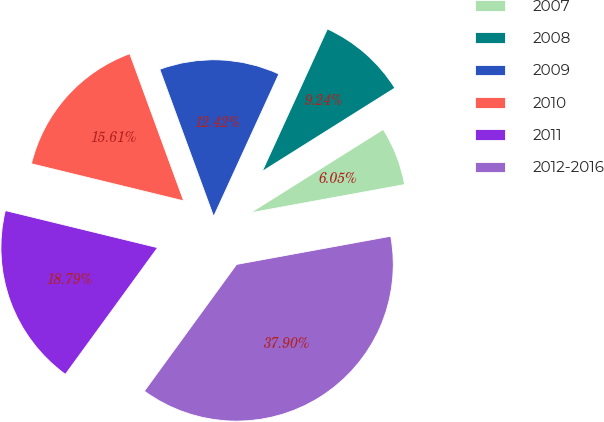Convert chart to OTSL. <chart><loc_0><loc_0><loc_500><loc_500><pie_chart><fcel>2007<fcel>2008<fcel>2009<fcel>2010<fcel>2011<fcel>2012-2016<nl><fcel>6.05%<fcel>9.24%<fcel>12.42%<fcel>15.61%<fcel>18.79%<fcel>37.9%<nl></chart> 